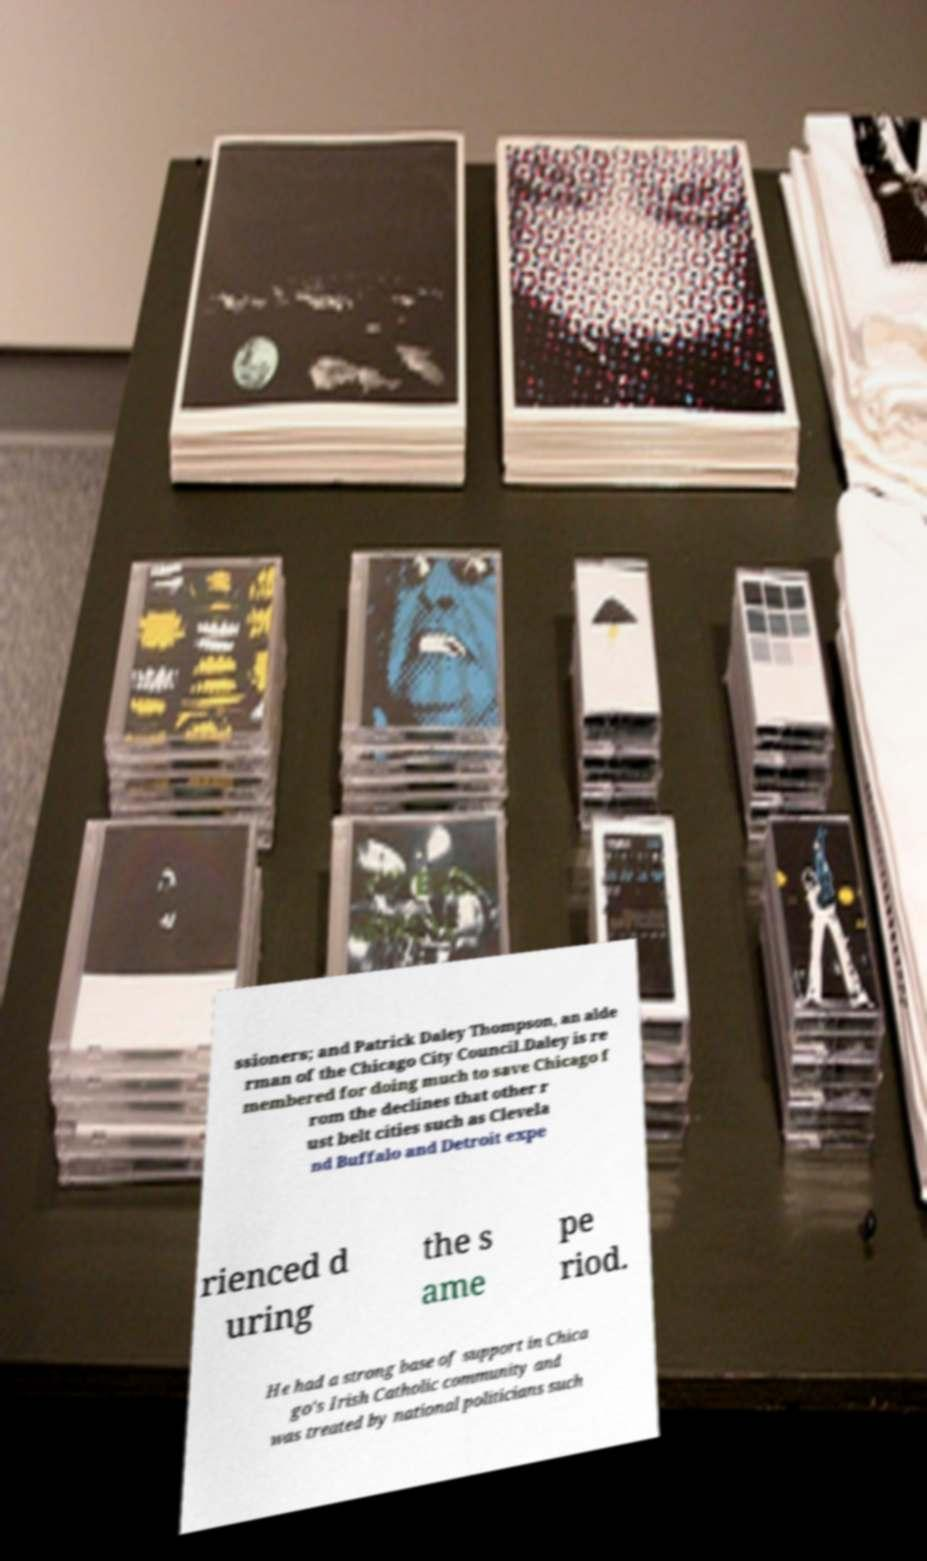For documentation purposes, I need the text within this image transcribed. Could you provide that? ssioners; and Patrick Daley Thompson, an alde rman of the Chicago City Council.Daley is re membered for doing much to save Chicago f rom the declines that other r ust belt cities such as Clevela nd Buffalo and Detroit expe rienced d uring the s ame pe riod. He had a strong base of support in Chica go's Irish Catholic community and was treated by national politicians such 